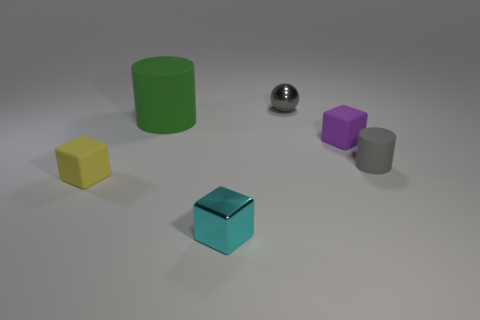Is there anything else that has the same size as the green cylinder?
Ensure brevity in your answer.  No. Does the tiny yellow cube have the same material as the gray object on the left side of the purple cube?
Your response must be concise. No. Is there anything else that has the same shape as the small gray metal thing?
Your answer should be very brief. No. There is a block that is on the right side of the yellow block and behind the cyan shiny cube; what color is it?
Your response must be concise. Purple. What is the shape of the tiny gray object on the left side of the tiny cylinder?
Provide a short and direct response. Sphere. How big is the rubber cylinder that is left of the tiny gray thing in front of the gray thing that is on the left side of the tiny cylinder?
Ensure brevity in your answer.  Large. There is a block that is behind the tiny yellow thing; how many gray things are on the right side of it?
Give a very brief answer. 1. What size is the rubber object that is behind the small gray matte thing and on the left side of the small cyan thing?
Keep it short and to the point. Large. What number of metal things are either tiny brown cylinders or yellow blocks?
Offer a terse response. 0. What material is the tiny cylinder?
Offer a terse response. Rubber. 